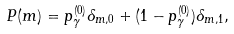Convert formula to latex. <formula><loc_0><loc_0><loc_500><loc_500>P ( m ) = p _ { \gamma } ^ { ( 0 ) } \delta _ { m , 0 } + ( 1 - p _ { \gamma } ^ { ( 0 ) } ) \delta _ { m , 1 } ,</formula> 